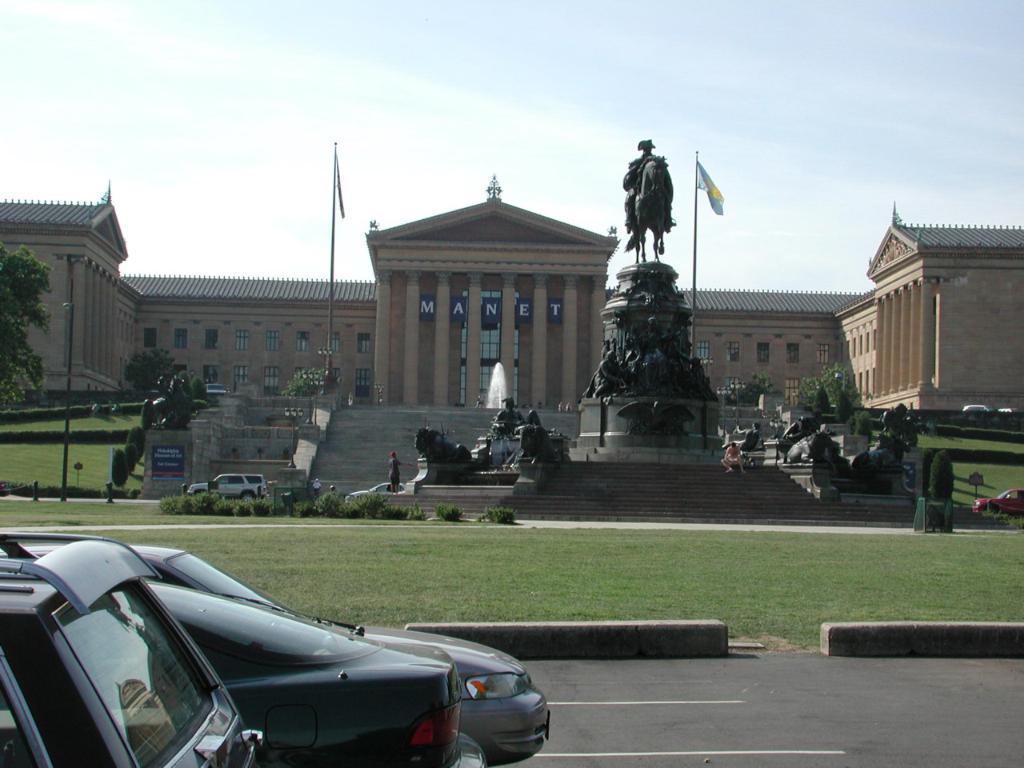Describe this image in one or two sentences. There are cars on the road. Here we can see grass, plants, poles, boards, flags, sculptures, trees, and a building. In the background there is sky. 